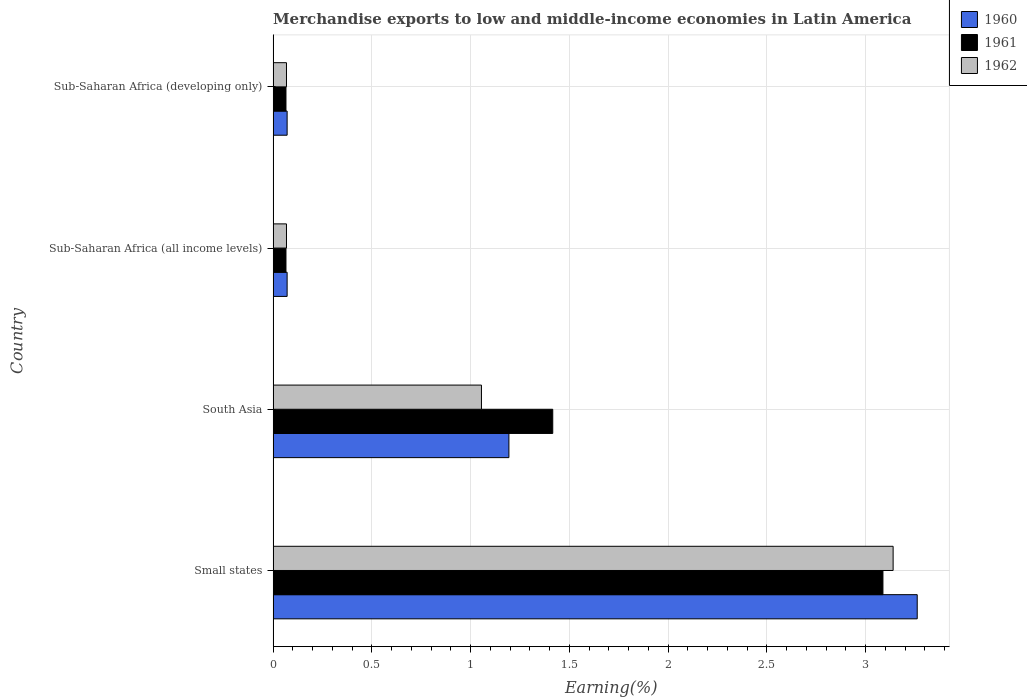How many different coloured bars are there?
Provide a short and direct response. 3. Are the number of bars on each tick of the Y-axis equal?
Provide a succinct answer. Yes. What is the label of the 3rd group of bars from the top?
Offer a very short reply. South Asia. In how many cases, is the number of bars for a given country not equal to the number of legend labels?
Your response must be concise. 0. What is the percentage of amount earned from merchandise exports in 1961 in South Asia?
Provide a short and direct response. 1.42. Across all countries, what is the maximum percentage of amount earned from merchandise exports in 1962?
Offer a terse response. 3.14. Across all countries, what is the minimum percentage of amount earned from merchandise exports in 1962?
Your response must be concise. 0.07. In which country was the percentage of amount earned from merchandise exports in 1960 maximum?
Make the answer very short. Small states. In which country was the percentage of amount earned from merchandise exports in 1962 minimum?
Provide a succinct answer. Sub-Saharan Africa (all income levels). What is the total percentage of amount earned from merchandise exports in 1960 in the graph?
Make the answer very short. 4.6. What is the difference between the percentage of amount earned from merchandise exports in 1960 in South Asia and that in Sub-Saharan Africa (all income levels)?
Offer a terse response. 1.12. What is the difference between the percentage of amount earned from merchandise exports in 1960 in Sub-Saharan Africa (developing only) and the percentage of amount earned from merchandise exports in 1961 in South Asia?
Offer a terse response. -1.34. What is the average percentage of amount earned from merchandise exports in 1960 per country?
Your answer should be compact. 1.15. What is the difference between the percentage of amount earned from merchandise exports in 1961 and percentage of amount earned from merchandise exports in 1962 in Sub-Saharan Africa (developing only)?
Make the answer very short. -0. In how many countries, is the percentage of amount earned from merchandise exports in 1960 greater than 2 %?
Your answer should be very brief. 1. What is the ratio of the percentage of amount earned from merchandise exports in 1962 in Sub-Saharan Africa (all income levels) to that in Sub-Saharan Africa (developing only)?
Ensure brevity in your answer.  1. What is the difference between the highest and the second highest percentage of amount earned from merchandise exports in 1961?
Make the answer very short. 1.67. What is the difference between the highest and the lowest percentage of amount earned from merchandise exports in 1960?
Offer a very short reply. 3.19. Is the sum of the percentage of amount earned from merchandise exports in 1960 in Sub-Saharan Africa (all income levels) and Sub-Saharan Africa (developing only) greater than the maximum percentage of amount earned from merchandise exports in 1962 across all countries?
Offer a terse response. No. What does the 3rd bar from the bottom in Sub-Saharan Africa (developing only) represents?
Your answer should be very brief. 1962. How many bars are there?
Provide a short and direct response. 12. Are all the bars in the graph horizontal?
Give a very brief answer. Yes. How many countries are there in the graph?
Your response must be concise. 4. What is the difference between two consecutive major ticks on the X-axis?
Your answer should be very brief. 0.5. Are the values on the major ticks of X-axis written in scientific E-notation?
Your answer should be compact. No. Does the graph contain any zero values?
Your answer should be very brief. No. Does the graph contain grids?
Make the answer very short. Yes. How are the legend labels stacked?
Make the answer very short. Vertical. What is the title of the graph?
Ensure brevity in your answer.  Merchandise exports to low and middle-income economies in Latin America. What is the label or title of the X-axis?
Your response must be concise. Earning(%). What is the label or title of the Y-axis?
Provide a short and direct response. Country. What is the Earning(%) of 1960 in Small states?
Your response must be concise. 3.26. What is the Earning(%) of 1961 in Small states?
Make the answer very short. 3.09. What is the Earning(%) in 1962 in Small states?
Provide a short and direct response. 3.14. What is the Earning(%) in 1960 in South Asia?
Your response must be concise. 1.19. What is the Earning(%) of 1961 in South Asia?
Give a very brief answer. 1.42. What is the Earning(%) in 1962 in South Asia?
Your answer should be compact. 1.05. What is the Earning(%) in 1960 in Sub-Saharan Africa (all income levels)?
Provide a short and direct response. 0.07. What is the Earning(%) of 1961 in Sub-Saharan Africa (all income levels)?
Your answer should be very brief. 0.07. What is the Earning(%) of 1962 in Sub-Saharan Africa (all income levels)?
Keep it short and to the point. 0.07. What is the Earning(%) of 1960 in Sub-Saharan Africa (developing only)?
Your answer should be compact. 0.07. What is the Earning(%) in 1961 in Sub-Saharan Africa (developing only)?
Provide a short and direct response. 0.07. What is the Earning(%) of 1962 in Sub-Saharan Africa (developing only)?
Your answer should be very brief. 0.07. Across all countries, what is the maximum Earning(%) of 1960?
Your response must be concise. 3.26. Across all countries, what is the maximum Earning(%) in 1961?
Provide a short and direct response. 3.09. Across all countries, what is the maximum Earning(%) in 1962?
Keep it short and to the point. 3.14. Across all countries, what is the minimum Earning(%) of 1960?
Your answer should be compact. 0.07. Across all countries, what is the minimum Earning(%) of 1961?
Your answer should be very brief. 0.07. Across all countries, what is the minimum Earning(%) of 1962?
Offer a terse response. 0.07. What is the total Earning(%) in 1960 in the graph?
Give a very brief answer. 4.6. What is the total Earning(%) in 1961 in the graph?
Your answer should be compact. 4.63. What is the total Earning(%) in 1962 in the graph?
Make the answer very short. 4.33. What is the difference between the Earning(%) of 1960 in Small states and that in South Asia?
Provide a succinct answer. 2.07. What is the difference between the Earning(%) in 1961 in Small states and that in South Asia?
Keep it short and to the point. 1.67. What is the difference between the Earning(%) in 1962 in Small states and that in South Asia?
Give a very brief answer. 2.08. What is the difference between the Earning(%) of 1960 in Small states and that in Sub-Saharan Africa (all income levels)?
Your response must be concise. 3.19. What is the difference between the Earning(%) of 1961 in Small states and that in Sub-Saharan Africa (all income levels)?
Ensure brevity in your answer.  3.02. What is the difference between the Earning(%) in 1962 in Small states and that in Sub-Saharan Africa (all income levels)?
Offer a terse response. 3.07. What is the difference between the Earning(%) in 1960 in Small states and that in Sub-Saharan Africa (developing only)?
Keep it short and to the point. 3.19. What is the difference between the Earning(%) in 1961 in Small states and that in Sub-Saharan Africa (developing only)?
Your answer should be compact. 3.02. What is the difference between the Earning(%) of 1962 in Small states and that in Sub-Saharan Africa (developing only)?
Your answer should be compact. 3.07. What is the difference between the Earning(%) in 1960 in South Asia and that in Sub-Saharan Africa (all income levels)?
Provide a succinct answer. 1.12. What is the difference between the Earning(%) of 1961 in South Asia and that in Sub-Saharan Africa (all income levels)?
Give a very brief answer. 1.35. What is the difference between the Earning(%) of 1962 in South Asia and that in Sub-Saharan Africa (all income levels)?
Your answer should be compact. 0.99. What is the difference between the Earning(%) in 1960 in South Asia and that in Sub-Saharan Africa (developing only)?
Give a very brief answer. 1.12. What is the difference between the Earning(%) in 1961 in South Asia and that in Sub-Saharan Africa (developing only)?
Your answer should be very brief. 1.35. What is the difference between the Earning(%) in 1962 in South Asia and that in Sub-Saharan Africa (developing only)?
Your answer should be very brief. 0.99. What is the difference between the Earning(%) of 1960 in Sub-Saharan Africa (all income levels) and that in Sub-Saharan Africa (developing only)?
Ensure brevity in your answer.  0. What is the difference between the Earning(%) of 1961 in Sub-Saharan Africa (all income levels) and that in Sub-Saharan Africa (developing only)?
Your answer should be compact. 0. What is the difference between the Earning(%) of 1960 in Small states and the Earning(%) of 1961 in South Asia?
Provide a short and direct response. 1.85. What is the difference between the Earning(%) in 1960 in Small states and the Earning(%) in 1962 in South Asia?
Ensure brevity in your answer.  2.21. What is the difference between the Earning(%) of 1961 in Small states and the Earning(%) of 1962 in South Asia?
Your response must be concise. 2.03. What is the difference between the Earning(%) in 1960 in Small states and the Earning(%) in 1961 in Sub-Saharan Africa (all income levels)?
Make the answer very short. 3.2. What is the difference between the Earning(%) in 1960 in Small states and the Earning(%) in 1962 in Sub-Saharan Africa (all income levels)?
Your answer should be compact. 3.19. What is the difference between the Earning(%) in 1961 in Small states and the Earning(%) in 1962 in Sub-Saharan Africa (all income levels)?
Your response must be concise. 3.02. What is the difference between the Earning(%) in 1960 in Small states and the Earning(%) in 1961 in Sub-Saharan Africa (developing only)?
Make the answer very short. 3.2. What is the difference between the Earning(%) in 1960 in Small states and the Earning(%) in 1962 in Sub-Saharan Africa (developing only)?
Make the answer very short. 3.19. What is the difference between the Earning(%) of 1961 in Small states and the Earning(%) of 1962 in Sub-Saharan Africa (developing only)?
Offer a very short reply. 3.02. What is the difference between the Earning(%) in 1960 in South Asia and the Earning(%) in 1961 in Sub-Saharan Africa (all income levels)?
Your response must be concise. 1.13. What is the difference between the Earning(%) of 1960 in South Asia and the Earning(%) of 1962 in Sub-Saharan Africa (all income levels)?
Provide a short and direct response. 1.13. What is the difference between the Earning(%) in 1961 in South Asia and the Earning(%) in 1962 in Sub-Saharan Africa (all income levels)?
Offer a very short reply. 1.35. What is the difference between the Earning(%) in 1960 in South Asia and the Earning(%) in 1961 in Sub-Saharan Africa (developing only)?
Give a very brief answer. 1.13. What is the difference between the Earning(%) in 1960 in South Asia and the Earning(%) in 1962 in Sub-Saharan Africa (developing only)?
Ensure brevity in your answer.  1.13. What is the difference between the Earning(%) of 1961 in South Asia and the Earning(%) of 1962 in Sub-Saharan Africa (developing only)?
Your answer should be very brief. 1.35. What is the difference between the Earning(%) of 1960 in Sub-Saharan Africa (all income levels) and the Earning(%) of 1961 in Sub-Saharan Africa (developing only)?
Offer a very short reply. 0.01. What is the difference between the Earning(%) in 1960 in Sub-Saharan Africa (all income levels) and the Earning(%) in 1962 in Sub-Saharan Africa (developing only)?
Make the answer very short. 0. What is the difference between the Earning(%) of 1961 in Sub-Saharan Africa (all income levels) and the Earning(%) of 1962 in Sub-Saharan Africa (developing only)?
Offer a terse response. -0. What is the average Earning(%) in 1960 per country?
Offer a terse response. 1.15. What is the average Earning(%) in 1961 per country?
Your answer should be very brief. 1.16. What is the average Earning(%) of 1962 per country?
Offer a very short reply. 1.08. What is the difference between the Earning(%) in 1960 and Earning(%) in 1961 in Small states?
Keep it short and to the point. 0.17. What is the difference between the Earning(%) of 1960 and Earning(%) of 1962 in Small states?
Provide a short and direct response. 0.12. What is the difference between the Earning(%) of 1961 and Earning(%) of 1962 in Small states?
Your answer should be compact. -0.05. What is the difference between the Earning(%) of 1960 and Earning(%) of 1961 in South Asia?
Provide a succinct answer. -0.22. What is the difference between the Earning(%) in 1960 and Earning(%) in 1962 in South Asia?
Provide a short and direct response. 0.14. What is the difference between the Earning(%) of 1961 and Earning(%) of 1962 in South Asia?
Keep it short and to the point. 0.36. What is the difference between the Earning(%) in 1960 and Earning(%) in 1961 in Sub-Saharan Africa (all income levels)?
Provide a short and direct response. 0.01. What is the difference between the Earning(%) of 1960 and Earning(%) of 1962 in Sub-Saharan Africa (all income levels)?
Provide a short and direct response. 0. What is the difference between the Earning(%) in 1961 and Earning(%) in 1962 in Sub-Saharan Africa (all income levels)?
Your answer should be very brief. -0. What is the difference between the Earning(%) of 1960 and Earning(%) of 1961 in Sub-Saharan Africa (developing only)?
Give a very brief answer. 0.01. What is the difference between the Earning(%) in 1960 and Earning(%) in 1962 in Sub-Saharan Africa (developing only)?
Your answer should be compact. 0. What is the difference between the Earning(%) in 1961 and Earning(%) in 1962 in Sub-Saharan Africa (developing only)?
Your response must be concise. -0. What is the ratio of the Earning(%) in 1960 in Small states to that in South Asia?
Ensure brevity in your answer.  2.73. What is the ratio of the Earning(%) of 1961 in Small states to that in South Asia?
Keep it short and to the point. 2.18. What is the ratio of the Earning(%) in 1962 in Small states to that in South Asia?
Keep it short and to the point. 2.98. What is the ratio of the Earning(%) of 1960 in Small states to that in Sub-Saharan Africa (all income levels)?
Your answer should be very brief. 46. What is the ratio of the Earning(%) of 1961 in Small states to that in Sub-Saharan Africa (all income levels)?
Make the answer very short. 47.48. What is the ratio of the Earning(%) of 1962 in Small states to that in Sub-Saharan Africa (all income levels)?
Provide a succinct answer. 46.39. What is the ratio of the Earning(%) of 1960 in Small states to that in Sub-Saharan Africa (developing only)?
Give a very brief answer. 46. What is the ratio of the Earning(%) in 1961 in Small states to that in Sub-Saharan Africa (developing only)?
Make the answer very short. 47.48. What is the ratio of the Earning(%) in 1962 in Small states to that in Sub-Saharan Africa (developing only)?
Your answer should be compact. 46.39. What is the ratio of the Earning(%) in 1960 in South Asia to that in Sub-Saharan Africa (all income levels)?
Your response must be concise. 16.84. What is the ratio of the Earning(%) of 1961 in South Asia to that in Sub-Saharan Africa (all income levels)?
Offer a terse response. 21.77. What is the ratio of the Earning(%) in 1962 in South Asia to that in Sub-Saharan Africa (all income levels)?
Offer a terse response. 15.59. What is the ratio of the Earning(%) of 1960 in South Asia to that in Sub-Saharan Africa (developing only)?
Make the answer very short. 16.84. What is the ratio of the Earning(%) in 1961 in South Asia to that in Sub-Saharan Africa (developing only)?
Your response must be concise. 21.77. What is the ratio of the Earning(%) of 1962 in South Asia to that in Sub-Saharan Africa (developing only)?
Your answer should be compact. 15.59. What is the difference between the highest and the second highest Earning(%) of 1960?
Offer a very short reply. 2.07. What is the difference between the highest and the second highest Earning(%) of 1961?
Your answer should be very brief. 1.67. What is the difference between the highest and the second highest Earning(%) of 1962?
Ensure brevity in your answer.  2.08. What is the difference between the highest and the lowest Earning(%) in 1960?
Make the answer very short. 3.19. What is the difference between the highest and the lowest Earning(%) in 1961?
Give a very brief answer. 3.02. What is the difference between the highest and the lowest Earning(%) in 1962?
Make the answer very short. 3.07. 